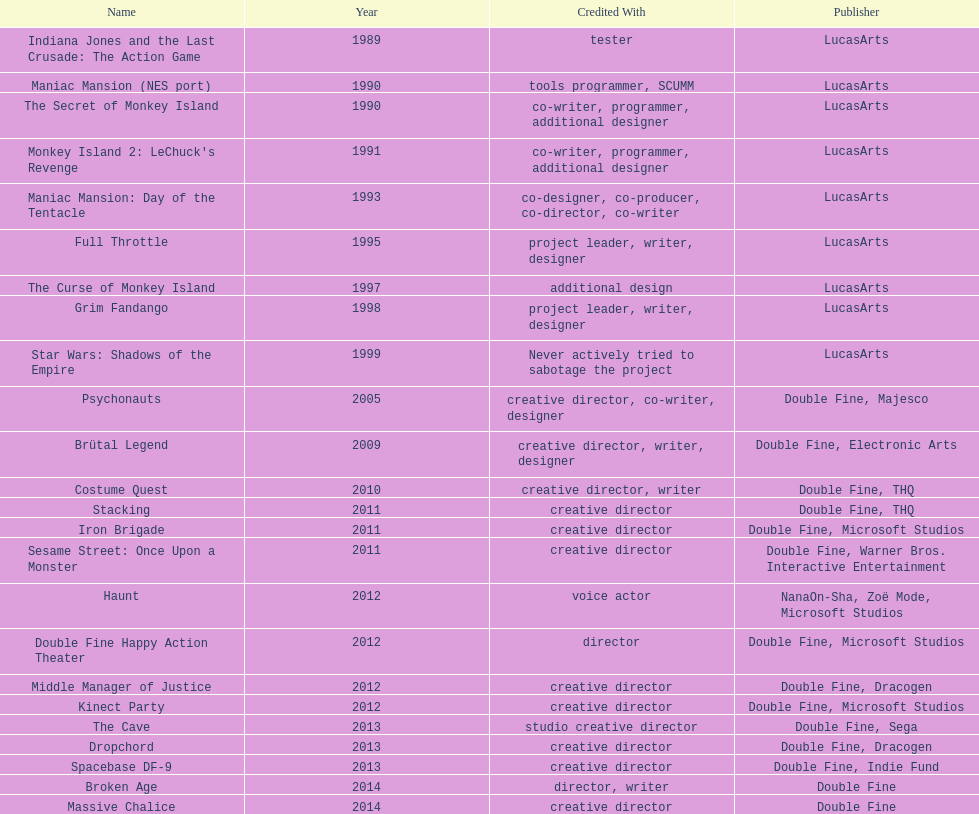What is the number of games that had a creative director credited? 11. 